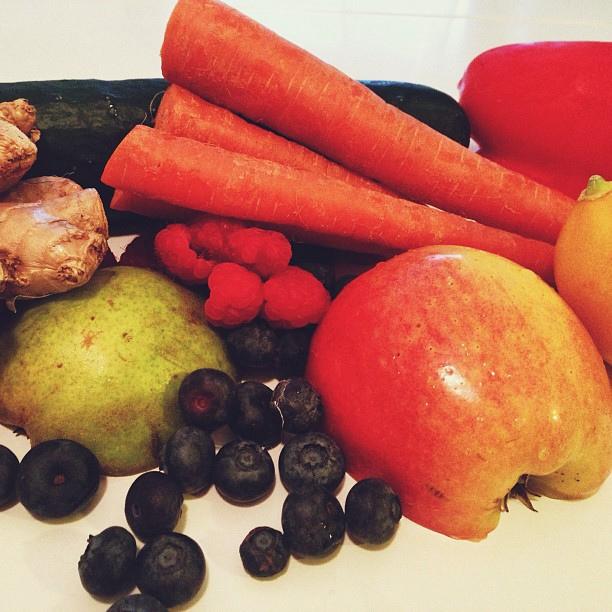Is some of the fruit cut in half?
Quick response, please. Yes. Would a vegetarian eat this meal?
Be succinct. Yes. What are the small, dark, round items?
Quick response, please. Blueberries. What color is the fruit behind the apple?
Concise answer only. Red. Is there ginger in this picture?
Short answer required. Yes. 